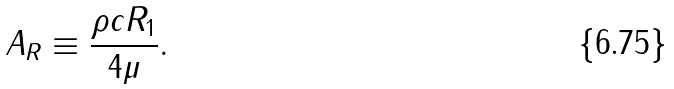Convert formula to latex. <formula><loc_0><loc_0><loc_500><loc_500>A _ { R } \equiv \frac { \rho c R _ { 1 } } { 4 \mu } .</formula> 